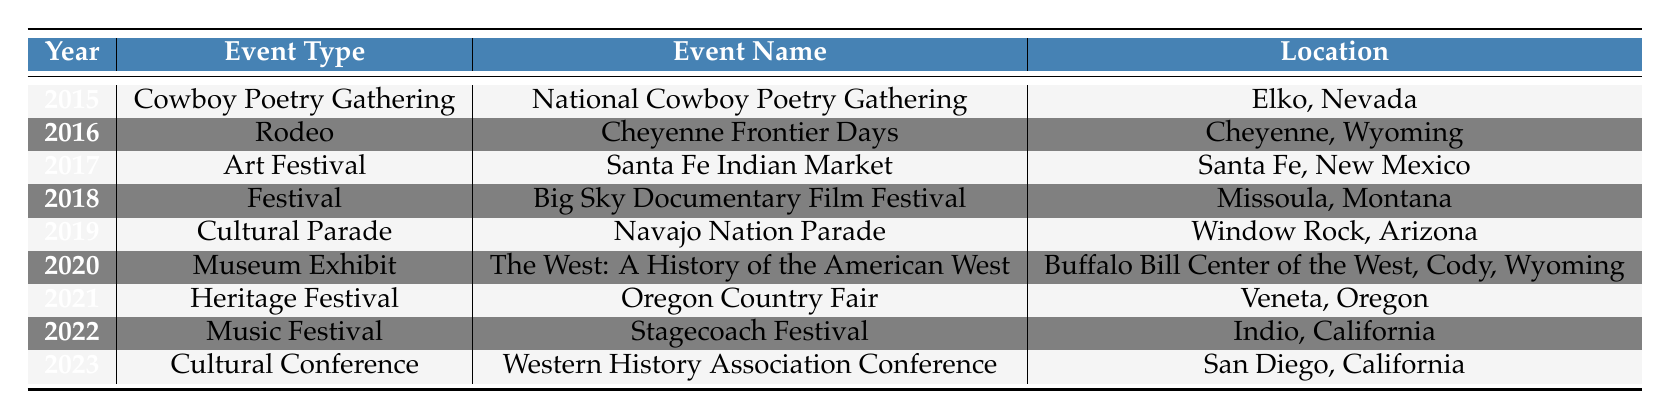What cultural event took place in 2020? According to the table, the event type listed for the year 2020 is a Museum Exhibit, and the event name is "The West: A History of the American West."
Answer: The West: A History of the American West Which event occurred in Elko, Nevada? The table indicates that the event held in Elko, Nevada, is the "National Cowboy Poetry Gathering," which took place in 2015.
Answer: National Cowboy Poetry Gathering How many years are represented in the table? The table lists events from the years 2015 to 2023, which totals 9 different years.
Answer: 9 Is there a cultural parade listed in the table? Yes, the table does list a cultural event of type "Cultural Parade," specifically the "Navajo Nation Parade" in the year 2019.
Answer: Yes What type of event was held in 2022, and where was it located? For the year 2022, the table shows a Music Festival named "Stagecoach Festival," which was located in Indio, California.
Answer: Music Festival, Indio, California What is the difference between the first and last years represented in the table? The first year represented is 2015, and the last is 2023. The difference is calculated as 2023 - 2015, which equals 8 years.
Answer: 8 How many different types of events are represented in the table? By analyzing the table, the following unique event types can be identified: Cowboy Poetry Gathering, Rodeo, Art Festival, Festival, Cultural Parade, Museum Exhibit, Heritage Festival, and Music Festival. This totals 8 distinct event types.
Answer: 8 Is the "Oregon Country Fair" an event type or an event name? The "Oregon Country Fair" is listed as an event name under the event type "Heritage Festival" in the year 2021.
Answer: Event name Which event type appears most frequently in the table? In the table, each event type appears only once, so none is more frequent than the others. Therefore, there is no event type that appears more than once.
Answer: None 